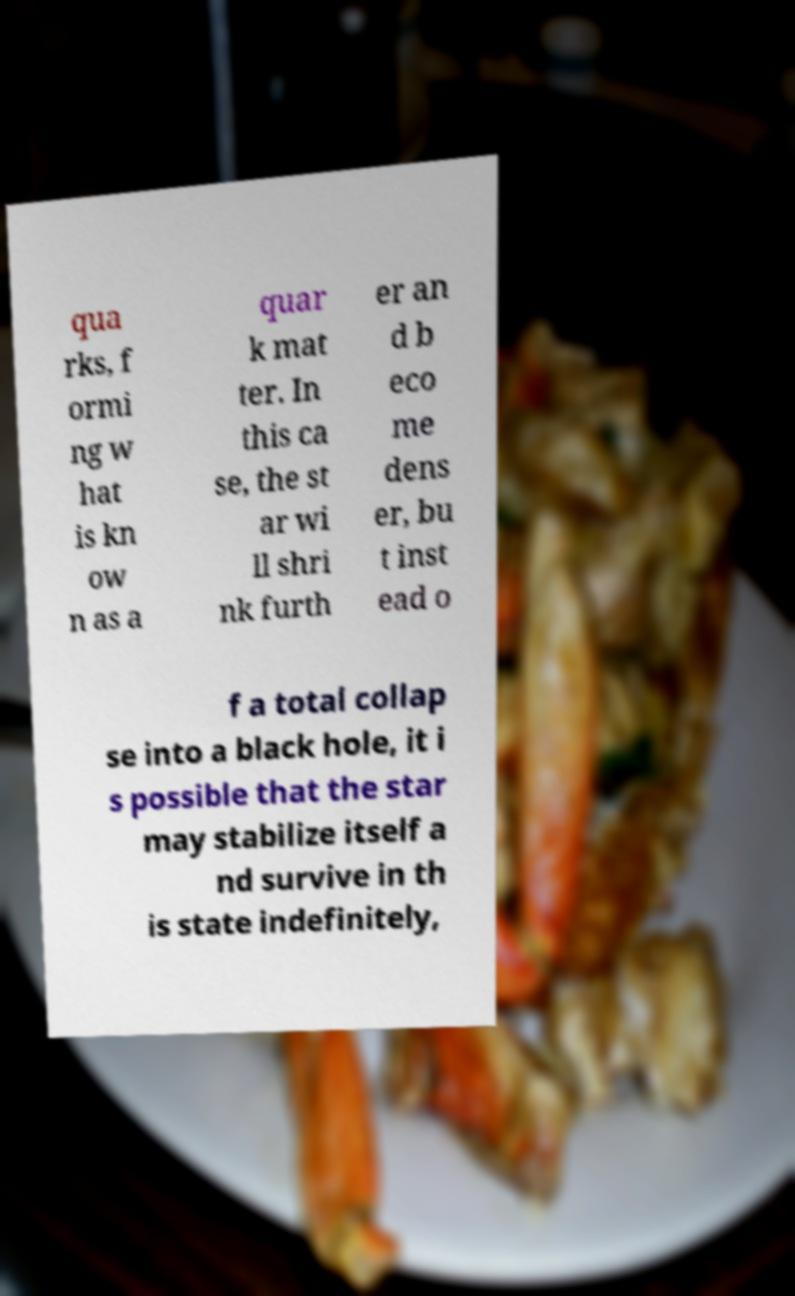Could you extract and type out the text from this image? qua rks, f ormi ng w hat is kn ow n as a quar k mat ter. In this ca se, the st ar wi ll shri nk furth er an d b eco me dens er, bu t inst ead o f a total collap se into a black hole, it i s possible that the star may stabilize itself a nd survive in th is state indefinitely, 